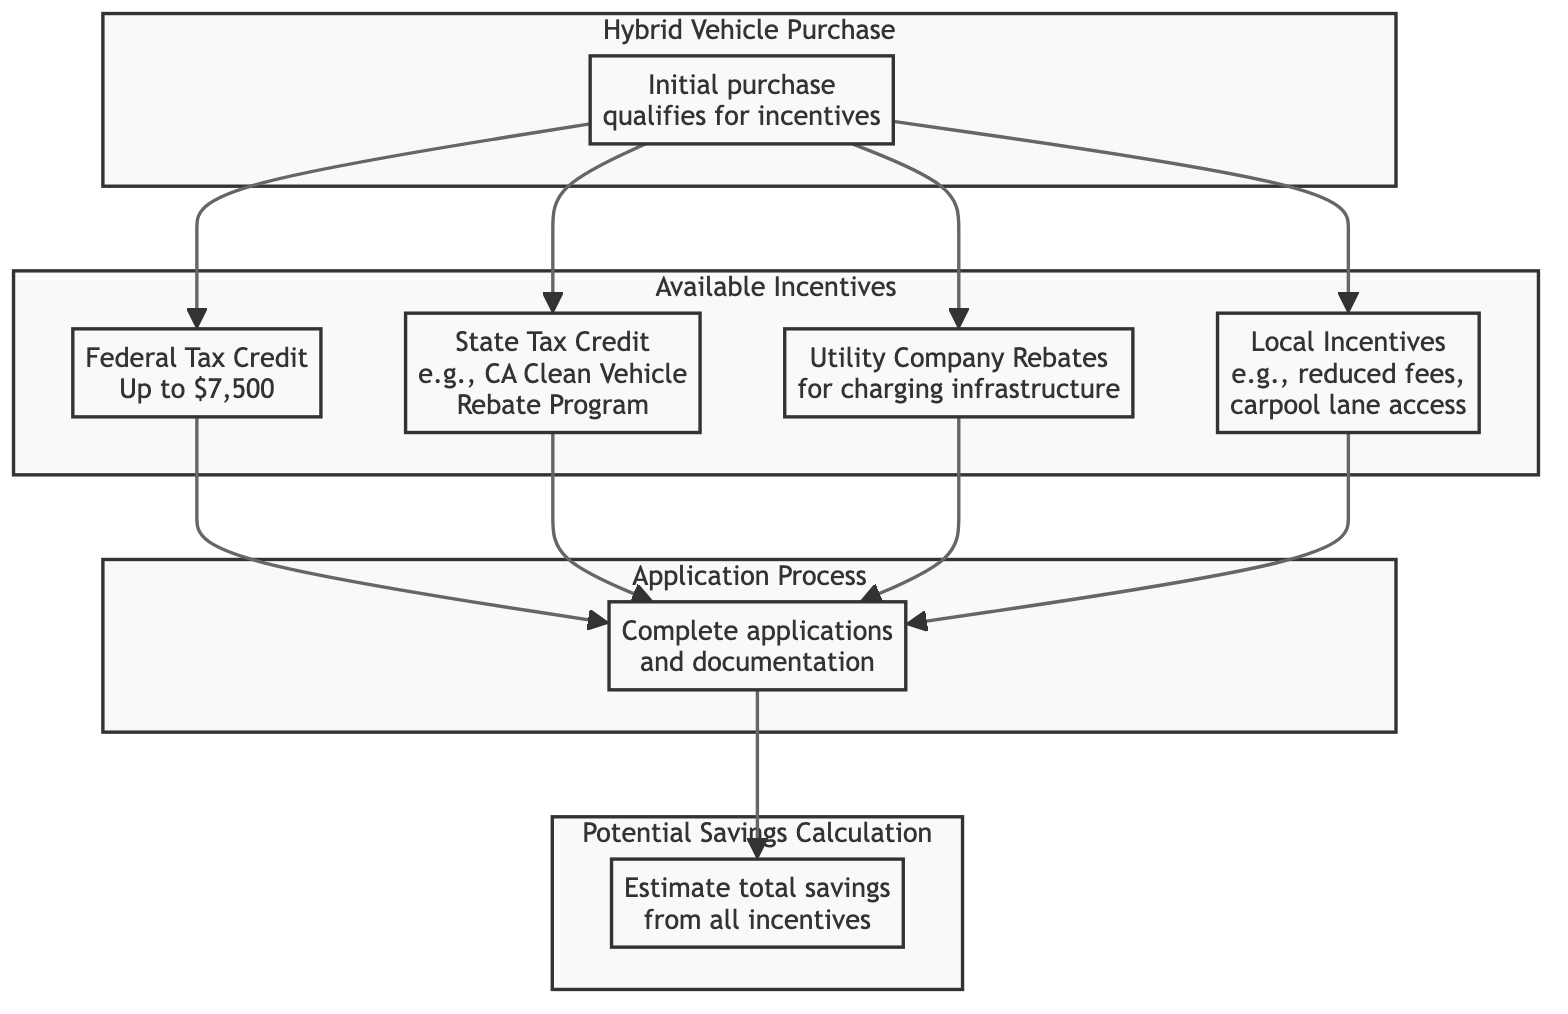What is the maximum federal tax credit available for hybrid vehicles? The diagram indicates that the federal tax credit for eligible hybrid vehicles can go up to $7,500. This information is directly represented in the node labeled "Federal Tax Credit."
Answer: $7,500 Which incentives are available after purchasing a hybrid vehicle? After the initial purchase of a hybrid vehicle, owners may qualify for four types of incentives listed in the diagram: Federal Tax Credit, State Tax Credit, Utility Company Rebates, and Local Incentives. This can be seen from the edges leading from the "Hybrid Vehicle Purchase" node to these incentive nodes.
Answer: Four What steps are involved in the application process for incentives? The diagram shows that the application process consists of completing applications and documentation, indicated in the "Application Process" node. It is the only step listed, showing that there is a singular process to follow after qualifying for incentives.
Answer: Complete applications and documentation Do utility company rebates depend on purchasing a hybrid vehicle? Yes, the diagram shows that utility company rebates are connected to the initial purchase of a hybrid vehicle; hence, they rely on it for qualification. The connection is evident from the flow from "Hybrid Vehicle Purchase" to "Utility Company Rebates."
Answer: Yes What is the relationship between available incentives and potential savings? The potential savings calculation is dependent on the application process, which is influenced by the available incentives. The nodes show that after completing applications, the next step is to estimate the total savings from all available incentives, demonstrating a clear progression.
Answer: The application process leads to potential savings Which type of incentives are local and specific to cities? The diagram identifies "Local Incentives" specifically, showing that they can include things like reduced registration fees or access to carpool lanes. This node is dedicated distinctly to local incentives based on geographical location, as illustrated by its labeling.
Answer: Local Incentives What are the possible savings to estimate provided by these incentives? Potential savings can be estimated by analyzing the total savings derived from all available incentives which include federal tax credit, state tax credit, utility company rebates, and local incentives, indicating a cumulative benefit. Each incentive contributes towards the overall potential savings.
Answer: Total savings from all incentives Which incentives must be completed first in the sequence? The order in the diagram shows that the "Hybrid Vehicle Purchase" must be completed first, as it is the starting point for qualifying for any incentives, indicated by the direction of flow leading from it.
Answer: Hybrid Vehicle Purchase How many types of incentives are listed in the diagram? The diagram lists four types of incentives specifically related to hybrid vehicle ownership: Federal Tax Credit, State Tax Credit, Utility Company Rebates, and Local Incentives. Counting these produces a total of four categories of incentives available after the purchase.
Answer: Four 